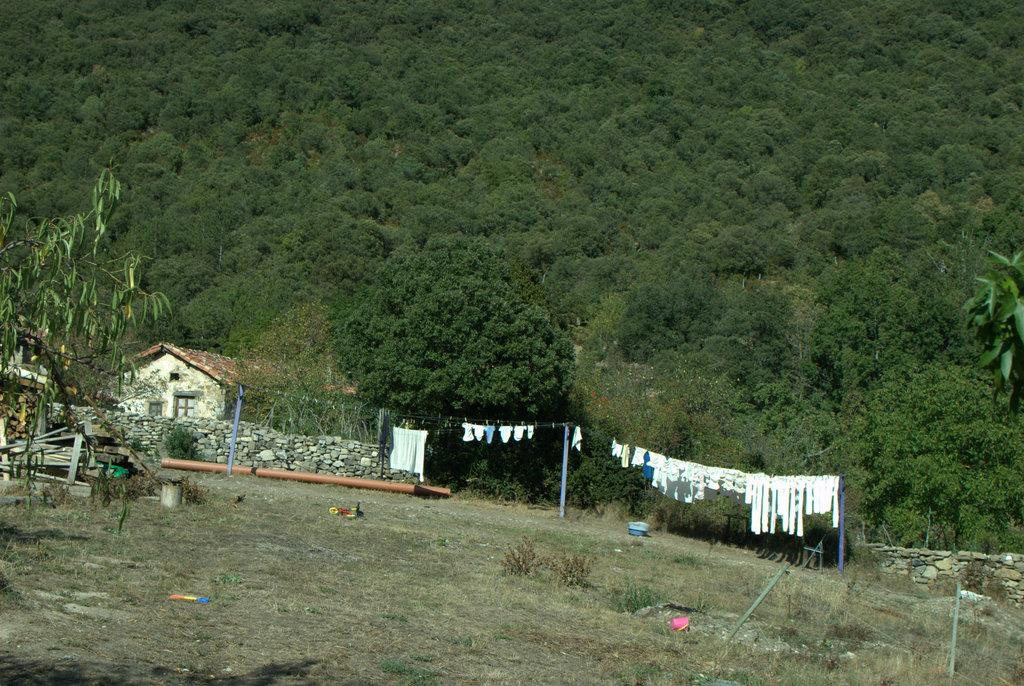What is the purpose of the rope in the image? Clothes are hung on a rope for drying in the image. What can be seen in the distance behind the rope? There are buildings and trees in the background of the image. What type of vegetation is present on the ground in the image? There are plants on the ground in the image. What else can be found on the ground in the image? There are other unspecified objects on the ground in the image. What songs are being sung by the stranger in the image? There is no stranger or singing present in the image. 